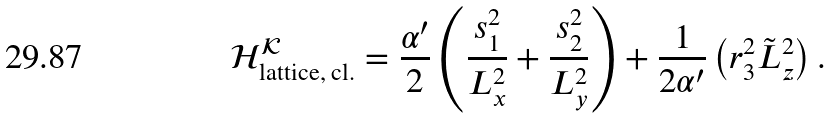Convert formula to latex. <formula><loc_0><loc_0><loc_500><loc_500>\mathcal { H } _ { \text {lattice, cl.} } ^ { \mathcal { K } } = \frac { \alpha ^ { \prime } } { 2 } \left ( \frac { s _ { 1 } ^ { 2 } } { L _ { x } ^ { 2 } } + \frac { s _ { 2 } ^ { 2 } } { L _ { y } ^ { 2 } } \right ) + \frac { 1 } { 2 \alpha ^ { \prime } } \left ( r _ { 3 } ^ { 2 } \tilde { L } _ { z } ^ { 2 } \right ) .</formula> 